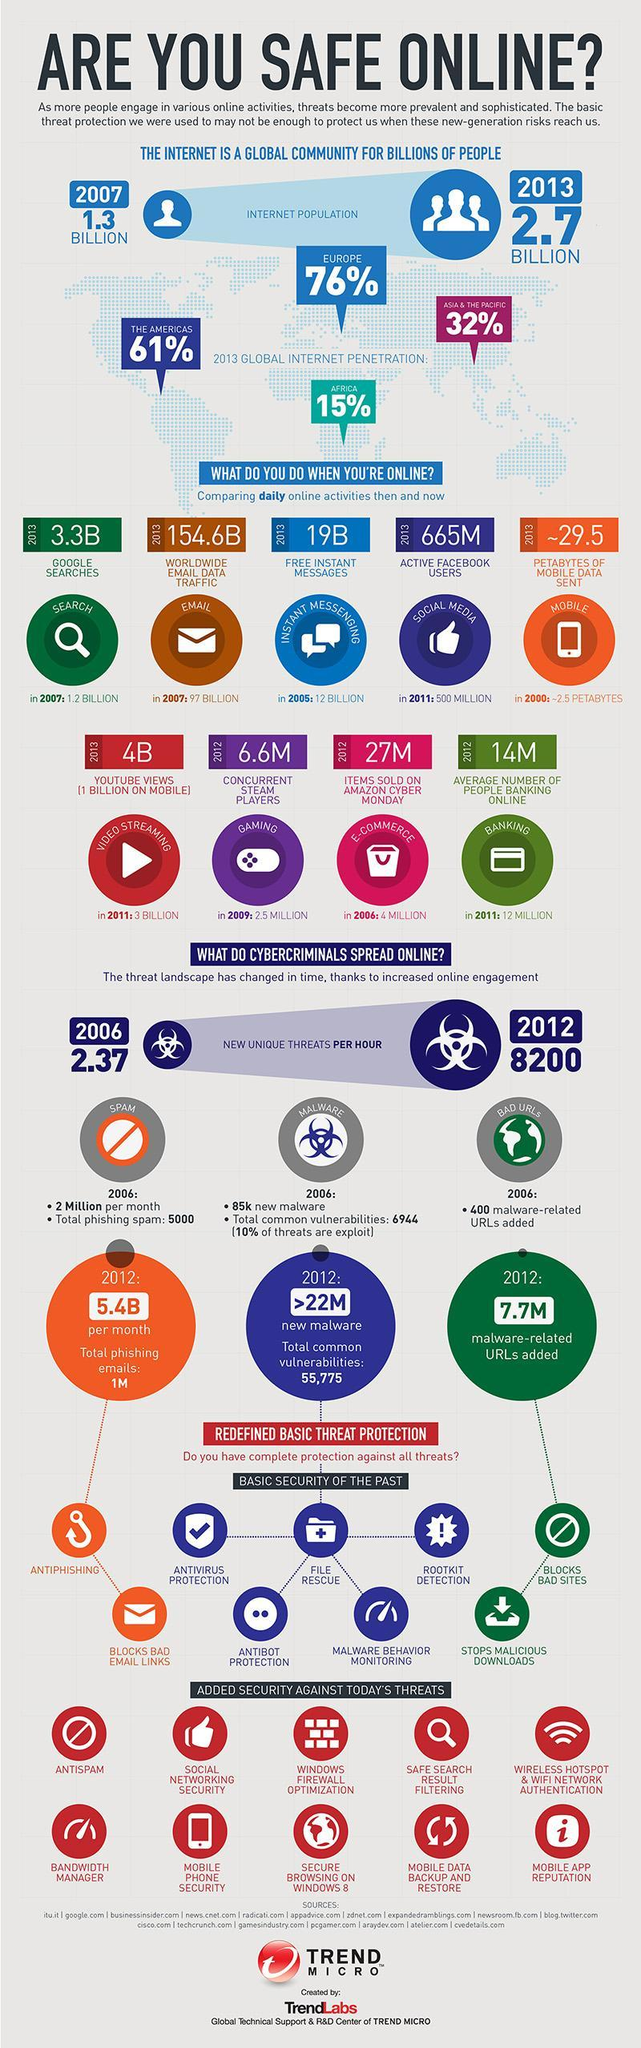For which online activity there were 2.5 million users in 2009?
Answer the question with a short phrase. gaming What was the total number of phishing emails sent in 2012? 1M What was the average number people banking online in 2011? 12 million How many items were sold on Amazon cyber Monday in 2006? 4 million How many petabytes of mobile data was sent in 2000? ~2.5 petabytes What was the number of Google searches in 2007? 1.2 Billion What was the number of free instant messages in 2013? 19B What does antiphishing software do? blocks bad email links What is the number of active Facebook users in 2013? 665M What was the worldwide email traffic in 2007? 97 billion 